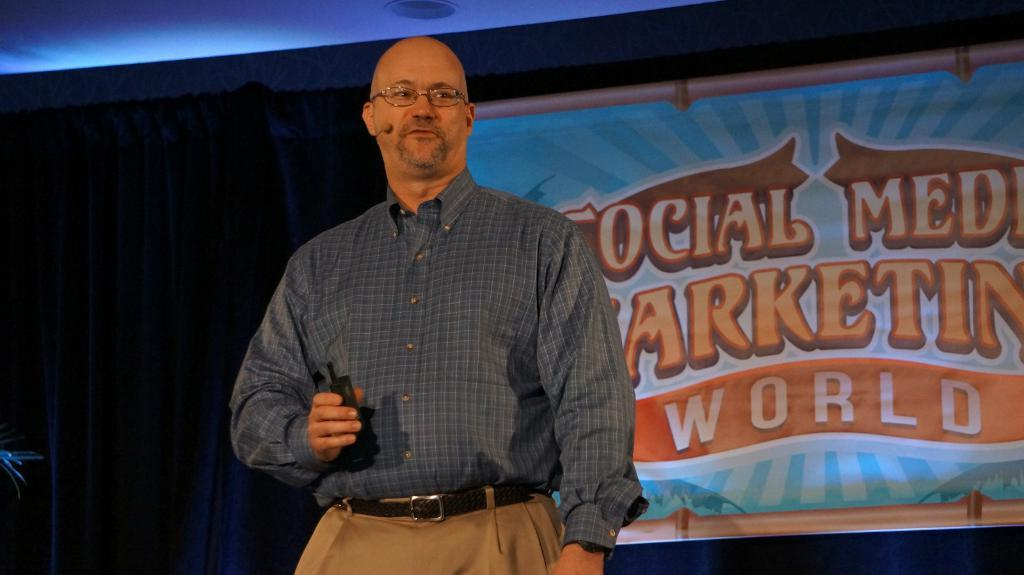Who is the person in the image? There is a man in the image. What is the man wearing that helps him see better? The man is wearing glasses (specs) in the image. What is the man holding in his hand? The man is holding a mic in the image. What can be seen in the background of the image? There is a curtain in the background of the image. What is written on the curtain? There is a banner on the curtain with text written on it. How many fingers does the man have on his left hand in the image? The image does not provide enough detail to determine the number of fingers the man has on his left hand. 